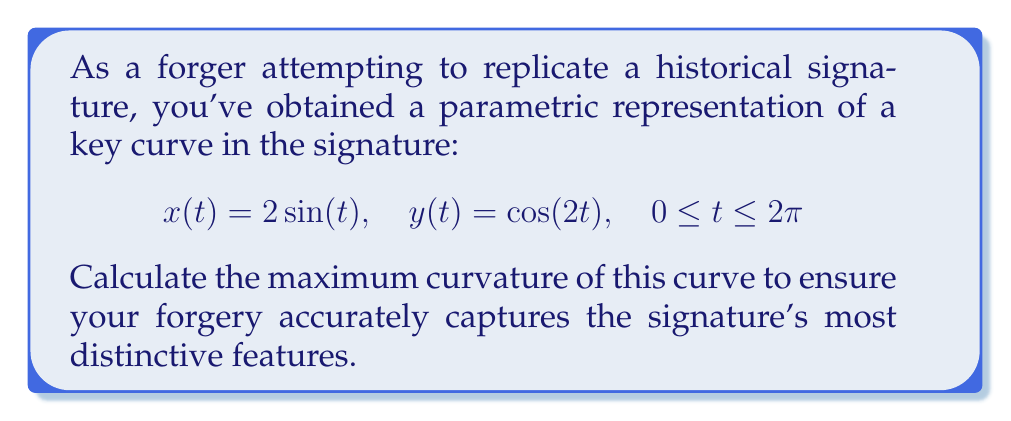Can you solve this math problem? To find the maximum curvature of the parametric curve, we'll follow these steps:

1) The curvature formula for a parametric curve is:

   $$\kappa = \frac{|x'y'' - y'x''|}{(x'^2 + y'^2)^{3/2}}$$

2) Calculate the first and second derivatives:
   $$x'(t) = 2\cos(t), \quad x''(t) = -2\sin(t)$$
   $$y'(t) = -2\sin(2t), \quad y''(t) = -4\cos(2t)$$

3) Substitute these into the curvature formula:

   $$\kappa = \frac{|2\cos(t)(-4\cos(2t)) - (-2\sin(2t))(-2\sin(t))|}{(4\cos^2(t) + 4\sin^2(2t))^{3/2}}$$

4) Simplify:
   $$\kappa = \frac{|-8\cos(t)\cos(2t) - 4\sin(t)\sin(2t)|}{(4\cos^2(t) + 4\sin^2(2t))^{3/2}}$$

5) Use the trigonometric identity $\cos(2t) = 2\cos^2(t) - 1$ and $\sin(2t) = 2\sin(t)\cos(t)$:

   $$\kappa = \frac{|-8\cos(t)(2\cos^2(t) - 1) - 8\sin^2(t)\cos(t)|}{(4\cos^2(t) + 16\sin^2(t)\cos^2(t))^{3/2}}$$

6) Simplify further:
   $$\kappa = \frac{|-16\cos^3(t) + 8\cos(t) - 8\sin^2(t)\cos(t)|}{(4\cos^2(t) + 16\sin^2(t)\cos^2(t))^{3/2}}$$

7) To find the maximum curvature, we need to find where the derivative of $\kappa$ with respect to $t$ is zero. However, this is a complex expression. Instead, we can observe that the numerator is bounded by 16 (the sum of the coefficients), while the denominator is minimized when $\sin(t) = 0$, i.e., when $t = 0$ or $\pi$.

8) At these points, the curvature becomes:

   $$\kappa(0) = \kappa(\pi) = \frac{16}{4^{3/2}} = 2$$

This is the maximum curvature of the curve.
Answer: The maximum curvature of the given parametric curve is 2. 